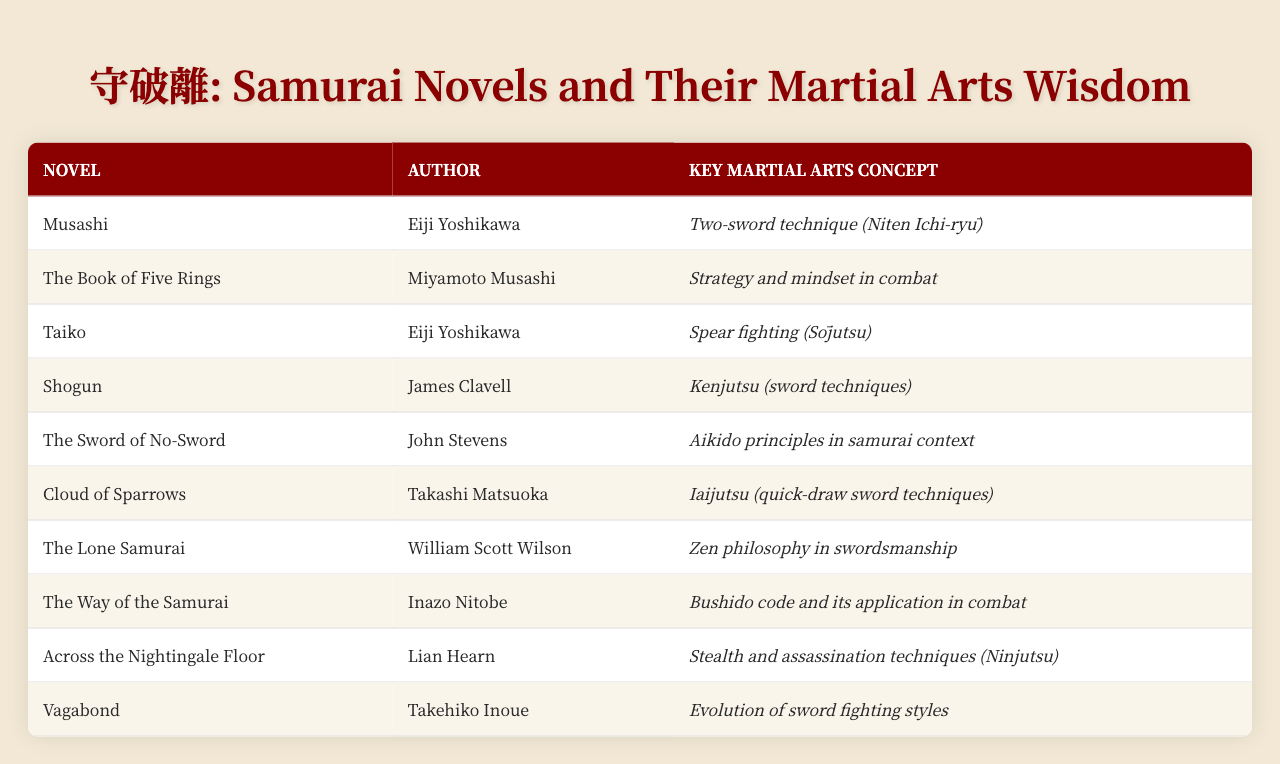What is the novel by Eiji Yoshikawa that focuses on the two-sword technique? The table lists "Musashi" by Eiji Yoshikawa, which highlights the two-sword technique (Niten Ichi-ryū) as its key martial arts concept.
Answer: Musashi Which author wrote the novel "The Book of Five Rings"? The table shows that "The Book of Five Rings" was authored by Miyamoto Musashi.
Answer: Miyamoto Musashi Is Kenjutsu mentioned in the table? Yes, the table indicates that "Shogun" by James Clavell features Kenjutsu, which refers to sword techniques.
Answer: Yes How many novels in the table focus on techniques that involve a sword? The novels "Musashi," "Shogun," "Cloud of Sparrows," and "Vagabond" each emphasize sword techniques, making a total of four.
Answer: 4 Which martial arts concept is associated with "Taiko"? The table states that "Taiko" by Eiji Yoshikawa is associated with spear fighting (Sōjutsu).
Answer: Spear fighting (Sōjutsu) Name the novel that discusses Zen philosophy in swordsmanship. The table identifies "The Lone Samurai" by William Scott Wilson as discussing Zen philosophy in swordsmanship.
Answer: The Lone Samurai What martial arts concept is linked to "Across the Nightingale Floor"? According to the table, "Across the Nightingale Floor" by Lian Hearn is linked to stealth and assassination techniques (Ninjutsu).
Answer: Stealth and assassination techniques (Ninjutsu) Which author has written the most novels listed in the table? By reviewing the table, we see that Eiji Yoshikawa has written two novels: "Musashi" and "Taiko," making him the most prolific author in this list.
Answer: Eiji Yoshikawa Do any novels in the table incorporate Aikido principles? Yes, "The Sword of No-Sword" by John Stevens incorporates Aikido principles in a samurai context, according to the table.
Answer: Yes What is the main martial arts concept portrayed in "The Way of the Samurai"? The table highlights that "The Way of the Samurai" by Inazo Nitobe portrays the Bushido code and its application in combat as its main concept.
Answer: Bushido code and its application in combat Is there a novel in the table by Takashi Matsuoka that emphasizes quick-draw sword techniques? Yes, "Cloud of Sparrows" by Takashi Matsuoka emphasizes Iaijutsu, which is focused on quick-draw sword techniques.
Answer: Yes 